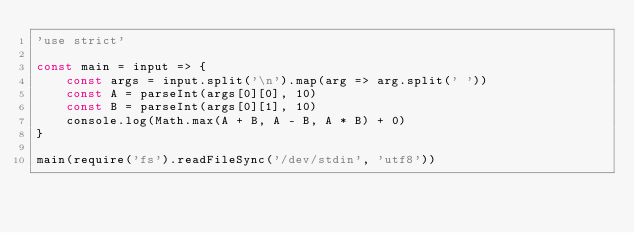<code> <loc_0><loc_0><loc_500><loc_500><_JavaScript_>'use strict'

const main = input => {
	const args = input.split('\n').map(arg => arg.split(' '))
	const A = parseInt(args[0][0], 10)
	const B = parseInt(args[0][1], 10)
	console.log(Math.max(A + B, A - B, A * B) + 0)
}

main(require('fs').readFileSync('/dev/stdin', 'utf8'))
</code> 